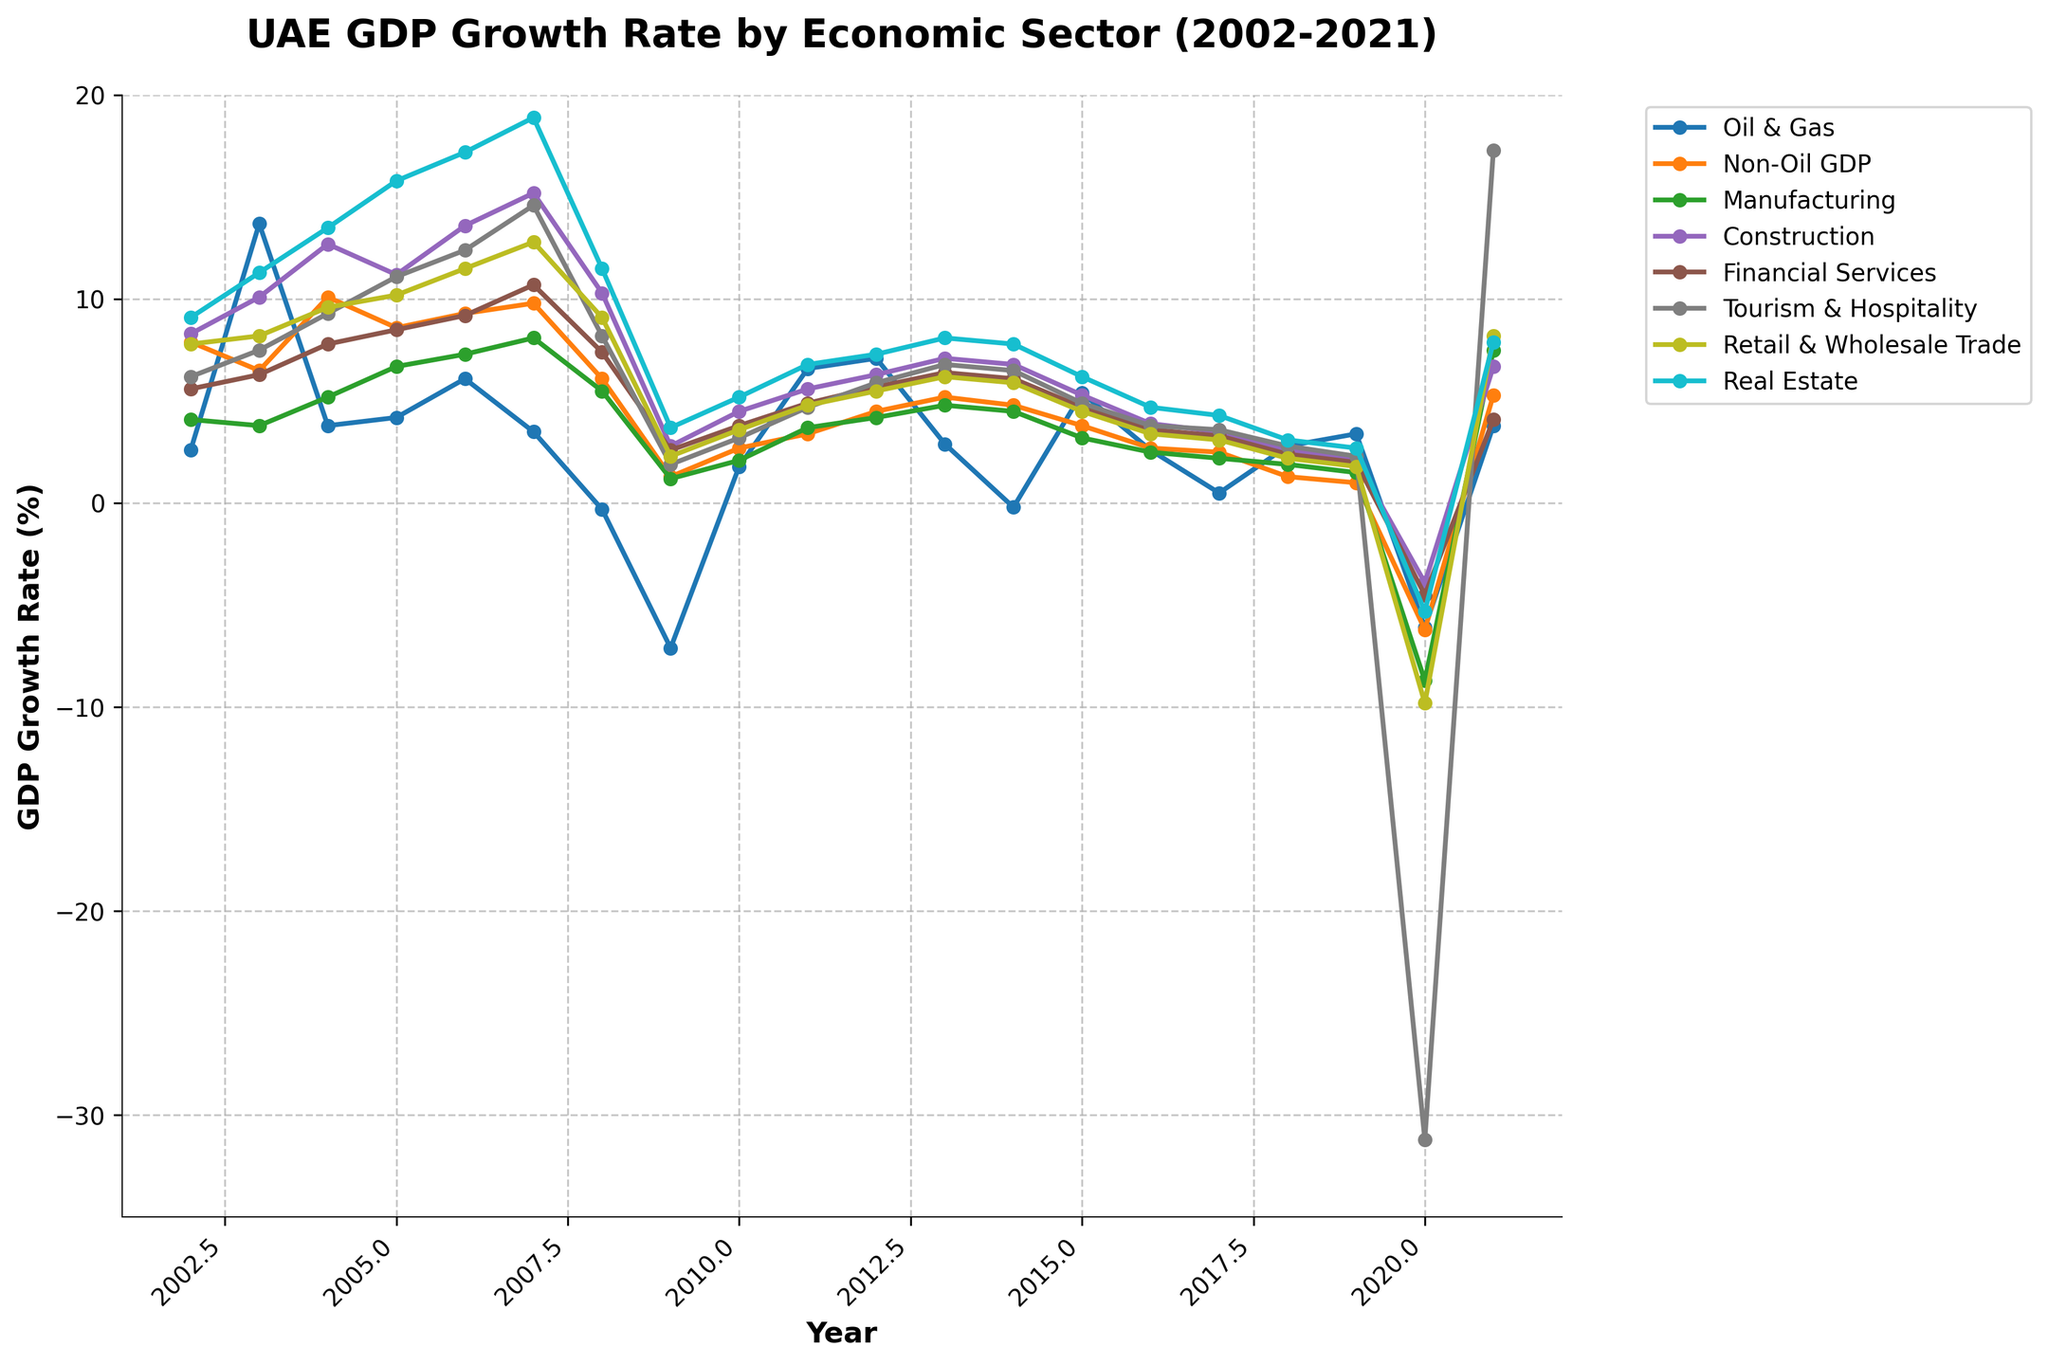Which sector experienced the highest GDP growth rate in 2007? To find the sector with the highest GDP growth rate in 2007, look at the data points in the year 2007 and identify the maximum value. The Real Estate sector has the highest point at 18.9%.
Answer: Real Estate How did the GDP growth rate of Oil & Gas in 2008 compare to 2009? To compare the GDP growth rate of Oil & Gas between 2008 and 2009, look at the values for those years. In 2008, the growth rate is -0.3% and in 2009, it is -7.1%. The GDP growth rate significantly decreased from 2008 to 2009.
Answer: It decreased Which sector showed the most decline in GDP growth rate in 2020? In 2020, identify the sector with the most negative value. The Tourism & Hospitality sector shows the most decline with a growth rate of -31.2%.
Answer: Tourism & Hospitality Compare the GDP growth rates of the Financial Services and Manufacturing sectors in 2005. Which one is higher? To compare, look at the GDP growth rates for Financial Services and Manufacturing in the year 2005. Financial Services show an 8.5% growth rate, while Manufacturing has a 6.7% growth rate. Financial Services is higher.
Answer: Financial Services What is the average GDP growth rate for the Non-Oil GDP sector over the period 2009 to 2013? Calculate the average by summing the GDP growth rates for the Non-Oil GDP sector from 2009 to 2013: (1.3 + 2.7 + 3.4 + 4.5 + 5.2) = 17.1, and then divide by 5. The average is 17.1 / 5 = 3.42%.
Answer: 3.42% Which sectors showed positive GDP growth rates in 2019? To identify sectors with positive growth rates in 2019, look at the values for that year. The sectors with positive growth rates are Oil & Gas (3.4%), Manufacturing (1.5%), Construction (2.1%), Financial Services (2.0%), Tourism & Hospitality (2.3%), and Real Estate (2.7%). Retail & Wholesale Trade (1.8%) also shows positive growth.
Answer: Oil & Gas, Manufacturing, Construction, Financial Services, Tourism & Hospitality, Retail & Wholesale Trade, Real Estate By how much did the GDP growth rate of Retail & Wholesale Trade change from 2019 to 2020? Calculate the change by subtracting the 2020 value from the 2019 value for Retail & Wholesale Trade. The values are (1.8% in 2019) and (-9.8% in 2020). The change is 1.8 - (-9.8) = 1.8 + 9.8 = 11.6%.
Answer: 11.6% What is the median GDP growth rate for the Real Estate sector over the entire period? Arrange the data points for Real Estate in ascending order and find the middle value. The sorted values are: (2.7, 3.1, 3.7, 4.3, 4.7, 5.2, 6.2, 6.8, 7.3, 7.8, 7.9, 8.1, 9.1, 11.3, 11.5, 13.5, 15.8, 17.2, 18.9). The median value is the 10th value, which is 7.9%.
Answer: 7.9% In which year did the Oil & Gas sector experience its lowest GDP growth rate? Look at the line for the Oil & Gas sector and identify the lowest point. The lowest GDP growth rate is -7.1% in the year 2009.
Answer: 2009 How does the GDP growth rate in 2021 of Tourism & Hospitality compare to the Construction sector? Compare the 2021 values for both Tourism & Hospitality (17.3%) and Construction (6.7%). Tourism & Hospitality has a higher GDP growth rate in 2021.
Answer: Tourism & Hospitality 